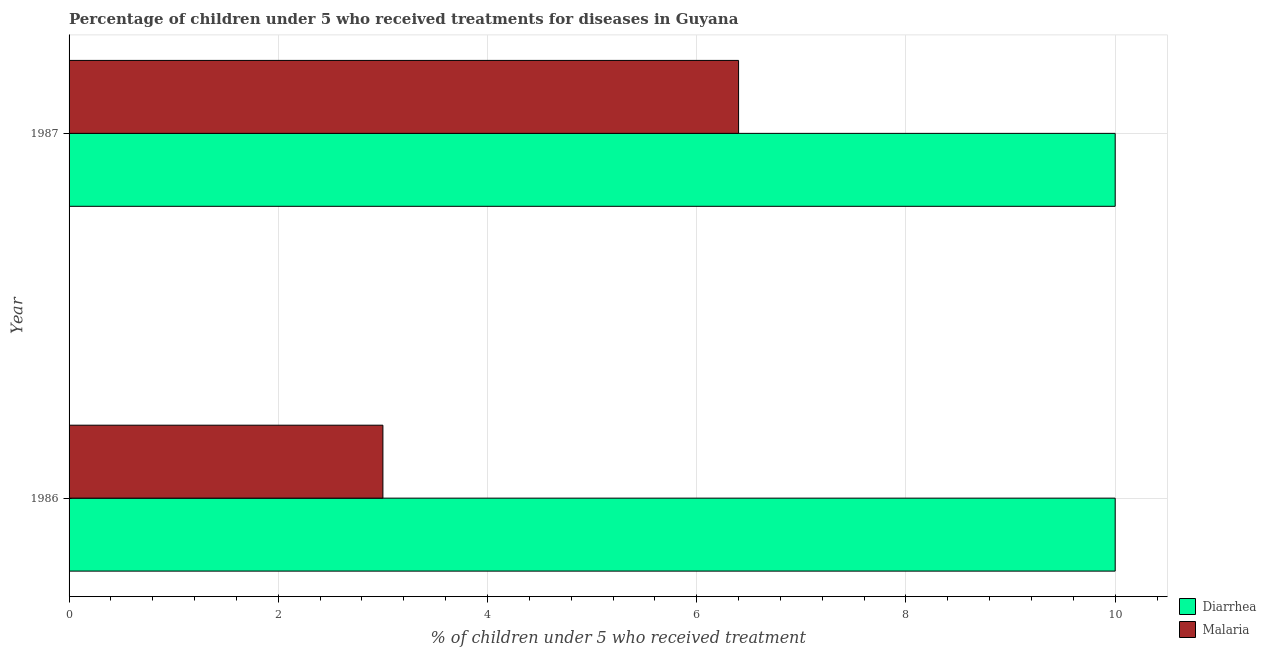How many groups of bars are there?
Ensure brevity in your answer.  2. Are the number of bars on each tick of the Y-axis equal?
Offer a terse response. Yes. What is the label of the 2nd group of bars from the top?
Offer a very short reply. 1986. In how many cases, is the number of bars for a given year not equal to the number of legend labels?
Your answer should be very brief. 0. What is the percentage of children who received treatment for malaria in 1986?
Provide a succinct answer. 3. Across all years, what is the maximum percentage of children who received treatment for diarrhoea?
Your answer should be very brief. 10. Across all years, what is the minimum percentage of children who received treatment for diarrhoea?
Ensure brevity in your answer.  10. What is the total percentage of children who received treatment for diarrhoea in the graph?
Make the answer very short. 20. What is the difference between the percentage of children who received treatment for diarrhoea in 1986 and that in 1987?
Keep it short and to the point. 0. What is the difference between the percentage of children who received treatment for diarrhoea in 1987 and the percentage of children who received treatment for malaria in 1986?
Ensure brevity in your answer.  7. What is the average percentage of children who received treatment for malaria per year?
Give a very brief answer. 4.7. In the year 1986, what is the difference between the percentage of children who received treatment for diarrhoea and percentage of children who received treatment for malaria?
Offer a terse response. 7. What is the ratio of the percentage of children who received treatment for malaria in 1986 to that in 1987?
Offer a very short reply. 0.47. Is the percentage of children who received treatment for diarrhoea in 1986 less than that in 1987?
Your answer should be very brief. No. In how many years, is the percentage of children who received treatment for diarrhoea greater than the average percentage of children who received treatment for diarrhoea taken over all years?
Ensure brevity in your answer.  0. What does the 2nd bar from the top in 1986 represents?
Make the answer very short. Diarrhea. What does the 2nd bar from the bottom in 1986 represents?
Make the answer very short. Malaria. How many bars are there?
Your response must be concise. 4. Are all the bars in the graph horizontal?
Your answer should be compact. Yes. Does the graph contain any zero values?
Your answer should be very brief. No. Does the graph contain grids?
Keep it short and to the point. Yes. Where does the legend appear in the graph?
Ensure brevity in your answer.  Bottom right. What is the title of the graph?
Provide a succinct answer. Percentage of children under 5 who received treatments for diseases in Guyana. What is the label or title of the X-axis?
Make the answer very short. % of children under 5 who received treatment. What is the % of children under 5 who received treatment in Diarrhea in 1986?
Ensure brevity in your answer.  10. What is the % of children under 5 who received treatment of Malaria in 1986?
Your response must be concise. 3. What is the % of children under 5 who received treatment of Diarrhea in 1987?
Your answer should be compact. 10. Across all years, what is the maximum % of children under 5 who received treatment in Malaria?
Provide a succinct answer. 6.4. Across all years, what is the minimum % of children under 5 who received treatment of Diarrhea?
Your answer should be compact. 10. What is the total % of children under 5 who received treatment in Malaria in the graph?
Your answer should be compact. 9.4. What is the average % of children under 5 who received treatment of Malaria per year?
Your response must be concise. 4.7. In the year 1986, what is the difference between the % of children under 5 who received treatment of Diarrhea and % of children under 5 who received treatment of Malaria?
Your answer should be compact. 7. In the year 1987, what is the difference between the % of children under 5 who received treatment in Diarrhea and % of children under 5 who received treatment in Malaria?
Your response must be concise. 3.6. What is the ratio of the % of children under 5 who received treatment of Diarrhea in 1986 to that in 1987?
Keep it short and to the point. 1. What is the ratio of the % of children under 5 who received treatment in Malaria in 1986 to that in 1987?
Offer a terse response. 0.47. What is the difference between the highest and the lowest % of children under 5 who received treatment of Diarrhea?
Offer a very short reply. 0. What is the difference between the highest and the lowest % of children under 5 who received treatment in Malaria?
Your answer should be very brief. 3.4. 